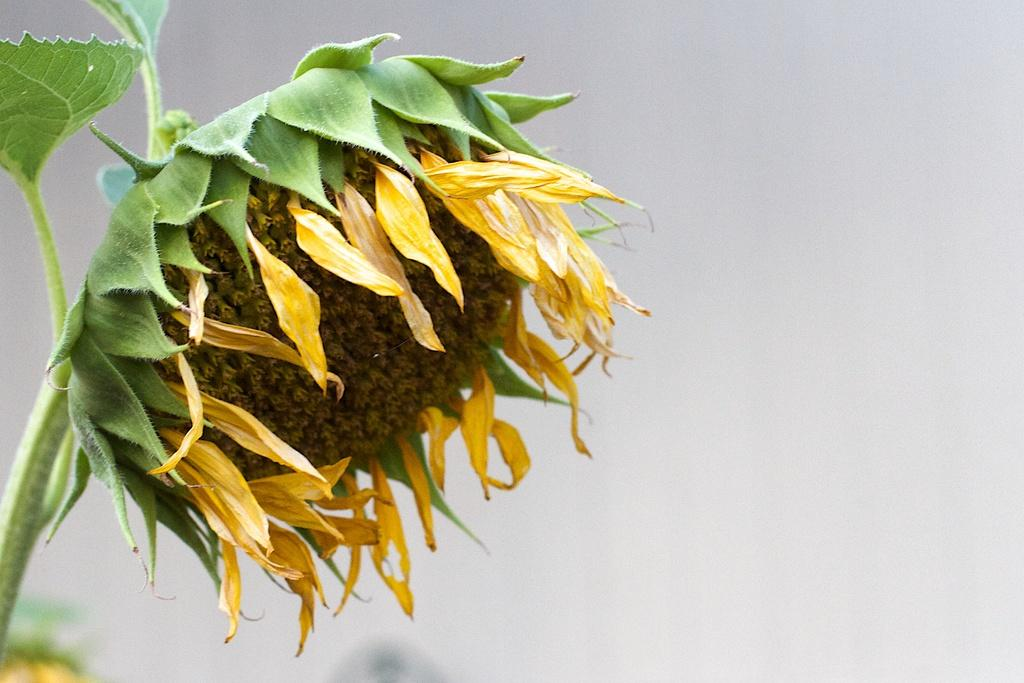Where was the image taken? The image was taken outdoors. What type of plant can be seen on the left side of the image? There is a plant with a sunflower on the left side of the image. What type of knife is being used to cut the sunflower in the image? There is no knife present in the image, and the sunflower is not being cut. 